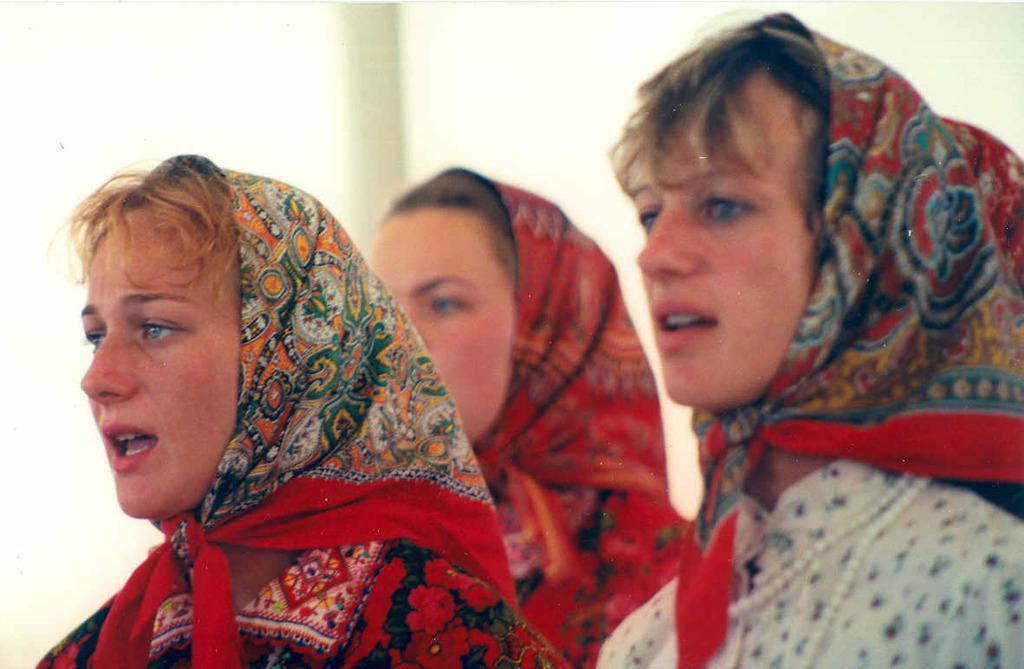How would you summarize this image in a sentence or two? In this image, there are some women standing and they are covering their heads with the scarves, at the background there is a wall. 